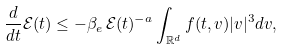<formula> <loc_0><loc_0><loc_500><loc_500>\frac { d } { d t } \mathcal { E } ( t ) \leq - \beta _ { e } \, \mathcal { E } ( t ) ^ { - a } \int _ { \mathbb { R } ^ { d } } f ( t , v ) | v | ^ { 3 } d v ,</formula> 